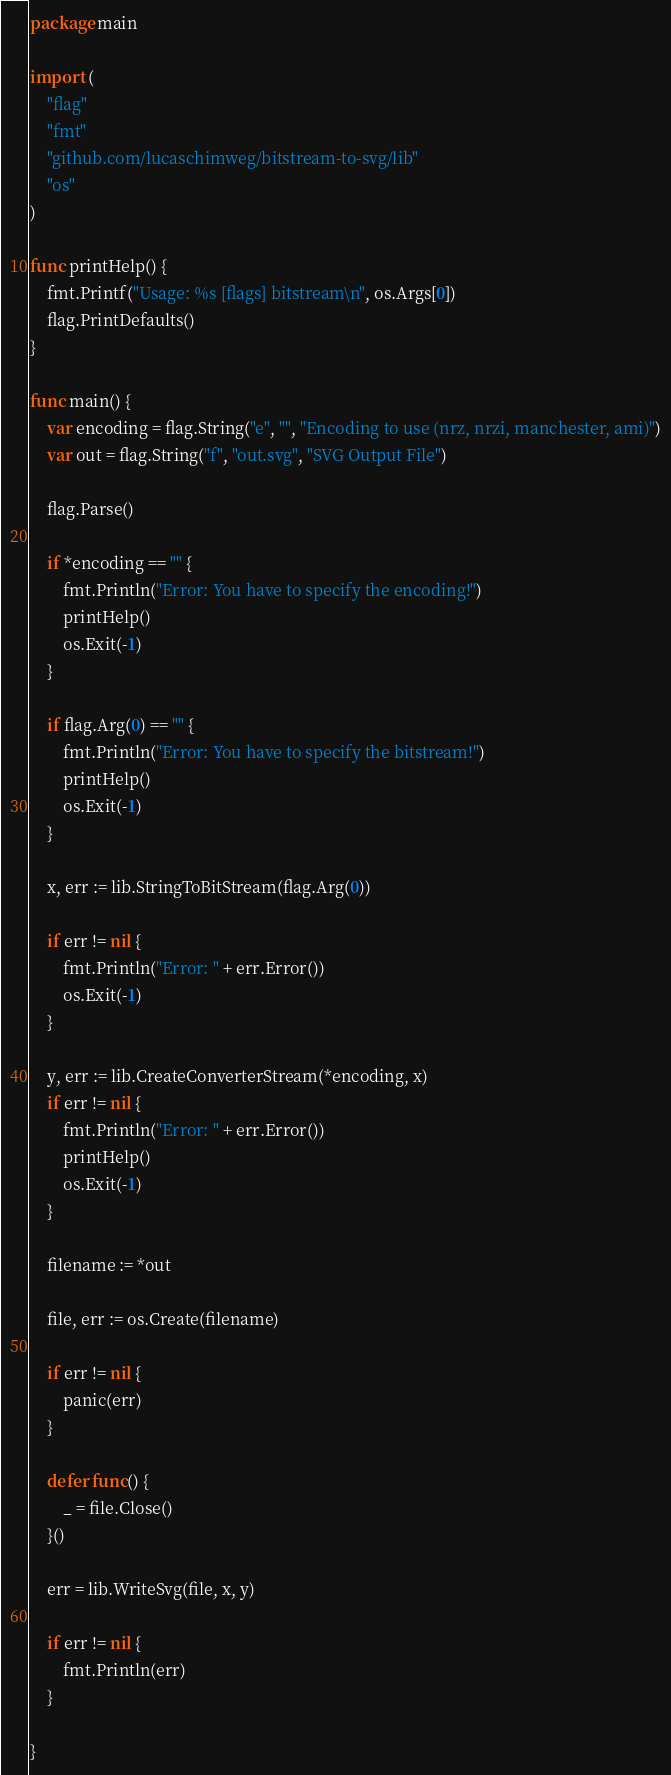<code> <loc_0><loc_0><loc_500><loc_500><_Go_>package main

import (
	"flag"
	"fmt"
	"github.com/lucaschimweg/bitstream-to-svg/lib"
	"os"
)

func printHelp() {
	fmt.Printf("Usage: %s [flags] bitstream\n", os.Args[0])
	flag.PrintDefaults()
}

func main() {
	var encoding = flag.String("e", "", "Encoding to use (nrz, nrzi, manchester, ami)")
	var out = flag.String("f", "out.svg", "SVG Output File")

	flag.Parse()

	if *encoding == "" {
		fmt.Println("Error: You have to specify the encoding!")
		printHelp()
		os.Exit(-1)
	}

	if flag.Arg(0) == "" {
		fmt.Println("Error: You have to specify the bitstream!")
		printHelp()
		os.Exit(-1)
	}

	x, err := lib.StringToBitStream(flag.Arg(0))

	if err != nil {
		fmt.Println("Error: " + err.Error())
		os.Exit(-1)
	}

	y, err := lib.CreateConverterStream(*encoding, x)
	if err != nil {
		fmt.Println("Error: " + err.Error())
		printHelp()
		os.Exit(-1)
	}

	filename := *out

	file, err := os.Create(filename)

	if err != nil {
		panic(err)
	}

	defer func() {
		_ = file.Close()
	}()

	err = lib.WriteSvg(file, x, y)

	if err != nil {
		fmt.Println(err)
	}

}
</code> 